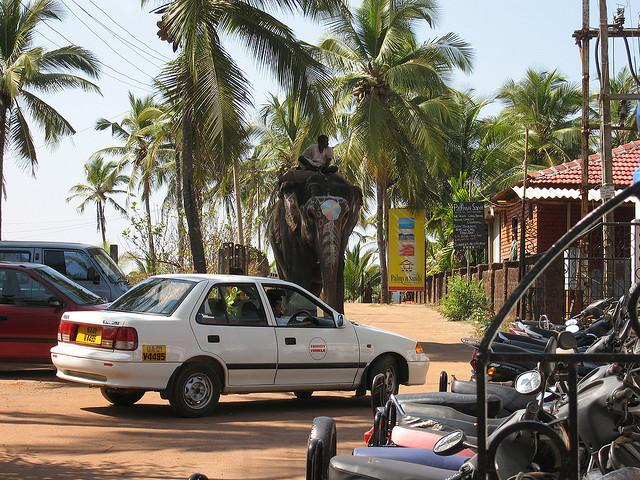What is this place? garage 